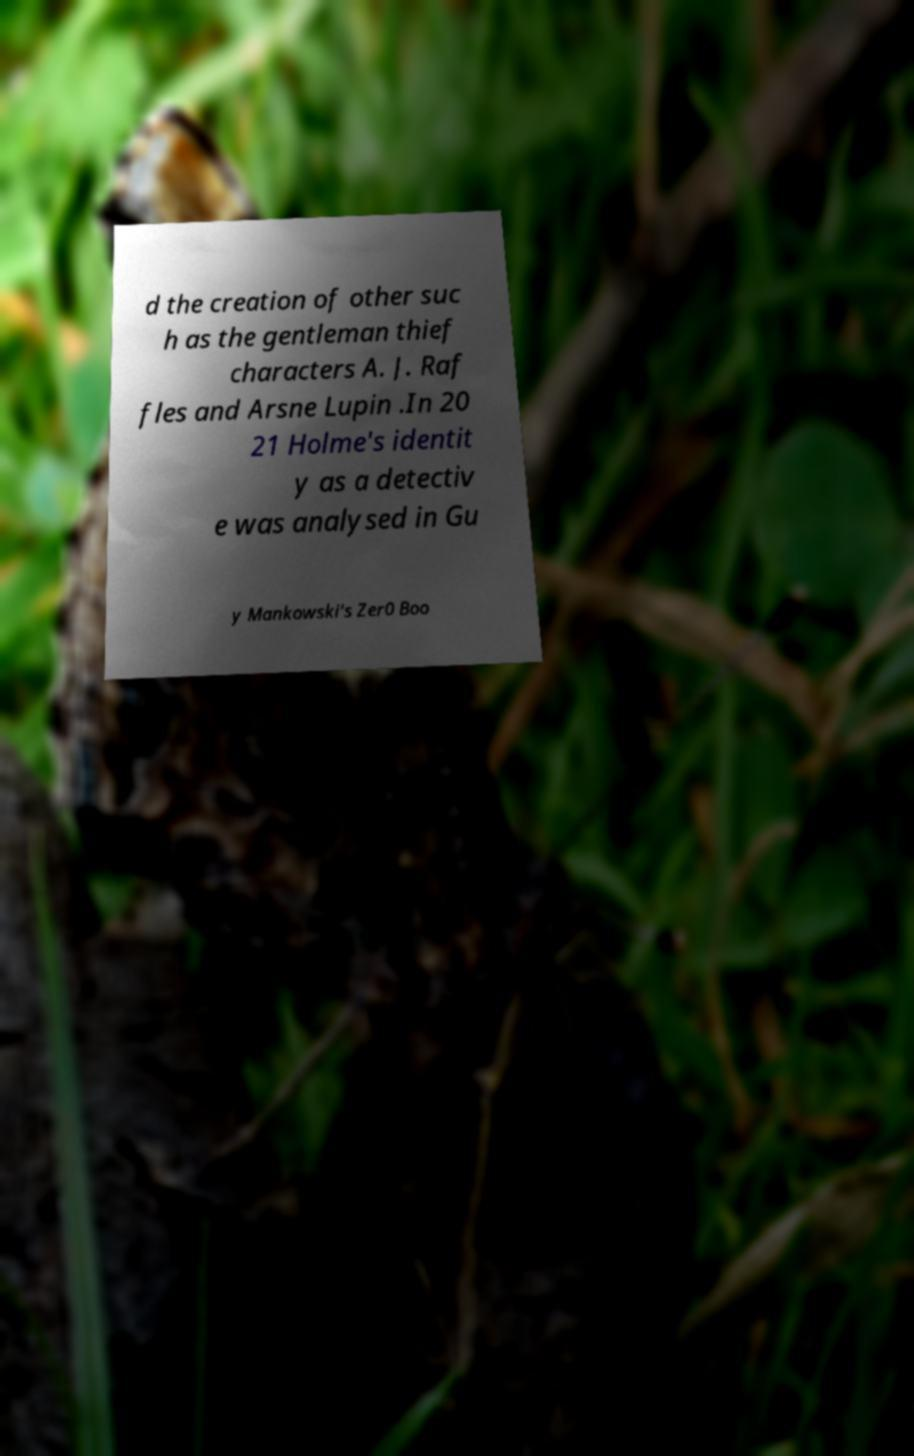Please identify and transcribe the text found in this image. d the creation of other suc h as the gentleman thief characters A. J. Raf fles and Arsne Lupin .In 20 21 Holme's identit y as a detectiv e was analysed in Gu y Mankowski's Zer0 Boo 